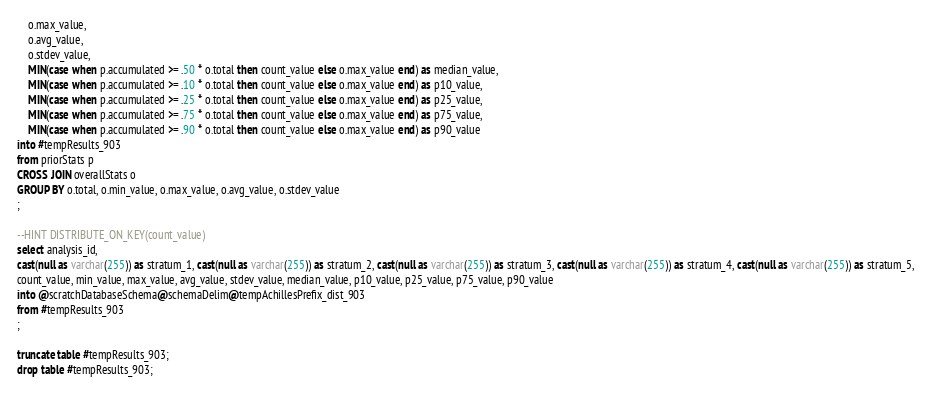Convert code to text. <code><loc_0><loc_0><loc_500><loc_500><_SQL_>	o.max_value,
	o.avg_value,
	o.stdev_value,
	MIN(case when p.accumulated >= .50 * o.total then count_value else o.max_value end) as median_value,
	MIN(case when p.accumulated >= .10 * o.total then count_value else o.max_value end) as p10_value,
	MIN(case when p.accumulated >= .25 * o.total then count_value else o.max_value end) as p25_value,
	MIN(case when p.accumulated >= .75 * o.total then count_value else o.max_value end) as p75_value,
	MIN(case when p.accumulated >= .90 * o.total then count_value else o.max_value end) as p90_value
into #tempResults_903
from priorStats p
CROSS JOIN overallStats o
GROUP BY o.total, o.min_value, o.max_value, o.avg_value, o.stdev_value
;

--HINT DISTRIBUTE_ON_KEY(count_value)
select analysis_id, 
cast(null as varchar(255)) as stratum_1, cast(null as varchar(255)) as stratum_2, cast(null as varchar(255)) as stratum_3, cast(null as varchar(255)) as stratum_4, cast(null as varchar(255)) as stratum_5,
count_value, min_value, max_value, avg_value, stdev_value, median_value, p10_value, p25_value, p75_value, p90_value
into @scratchDatabaseSchema@schemaDelim@tempAchillesPrefix_dist_903
from #tempResults_903
;

truncate table #tempResults_903;
drop table #tempResults_903;
</code> 